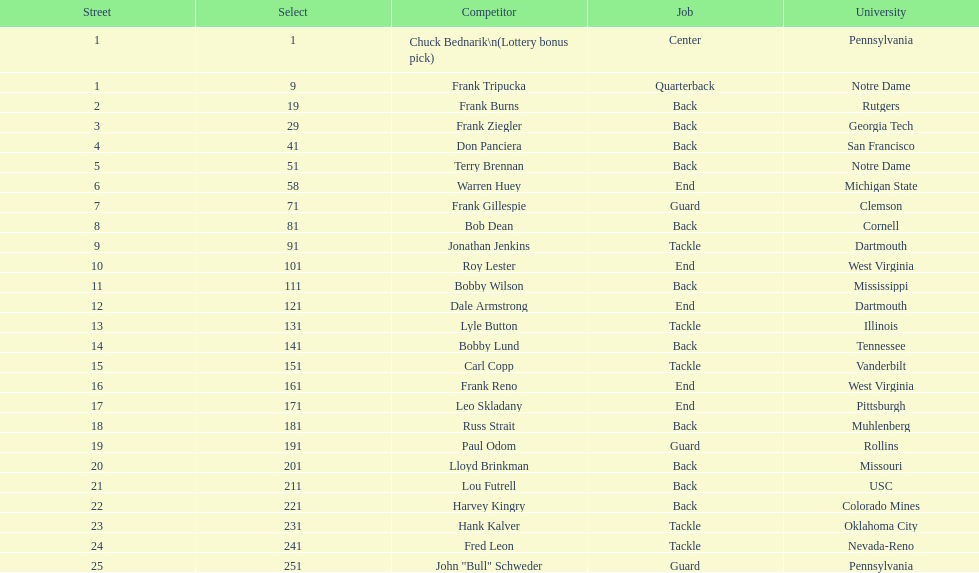What was the position that most of the players had? Back. 